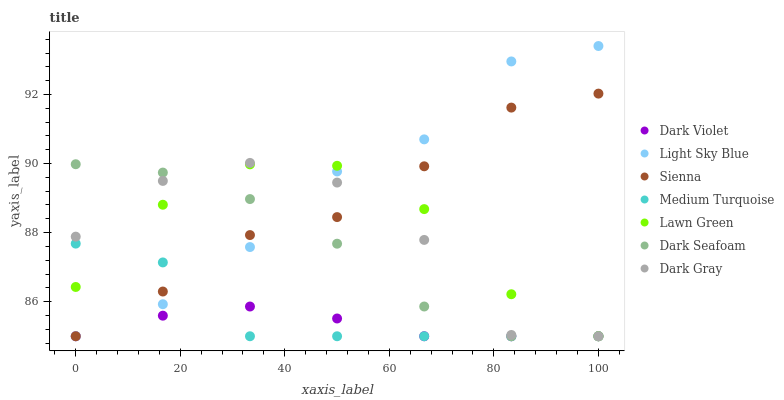Does Dark Violet have the minimum area under the curve?
Answer yes or no. Yes. Does Light Sky Blue have the maximum area under the curve?
Answer yes or no. Yes. Does Sienna have the minimum area under the curve?
Answer yes or no. No. Does Sienna have the maximum area under the curve?
Answer yes or no. No. Is Dark Violet the smoothest?
Answer yes or no. Yes. Is Dark Gray the roughest?
Answer yes or no. Yes. Is Sienna the smoothest?
Answer yes or no. No. Is Sienna the roughest?
Answer yes or no. No. Does Lawn Green have the lowest value?
Answer yes or no. Yes. Does Light Sky Blue have the highest value?
Answer yes or no. Yes. Does Sienna have the highest value?
Answer yes or no. No. Does Dark Violet intersect Sienna?
Answer yes or no. Yes. Is Dark Violet less than Sienna?
Answer yes or no. No. Is Dark Violet greater than Sienna?
Answer yes or no. No. 